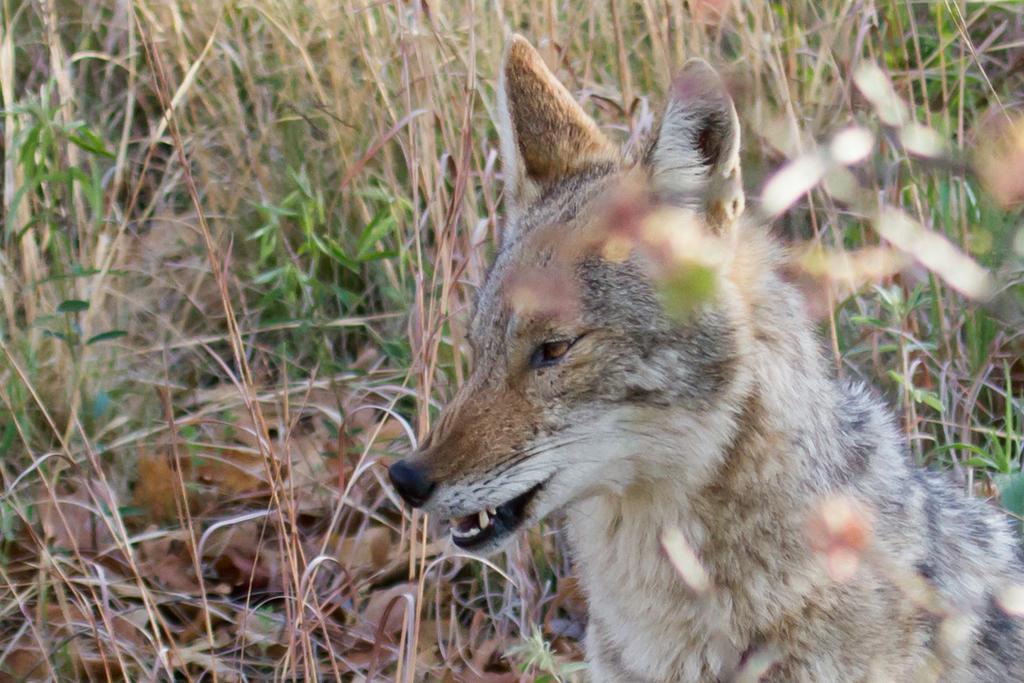Can you describe this image briefly? In this image there is a animal at the foreground. At the background of the image there is grass. 